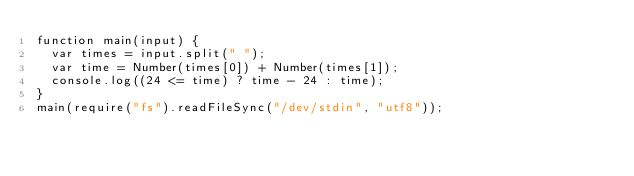<code> <loc_0><loc_0><loc_500><loc_500><_JavaScript_>function main(input) {
  var times = input.split(" ");
  var time = Number(times[0]) + Number(times[1]);
  console.log((24 <= time) ? time - 24 : time);
}
main(require("fs").readFileSync("/dev/stdin", "utf8"));
</code> 